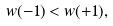<formula> <loc_0><loc_0><loc_500><loc_500>w ( - 1 ) < w ( + 1 ) ,</formula> 